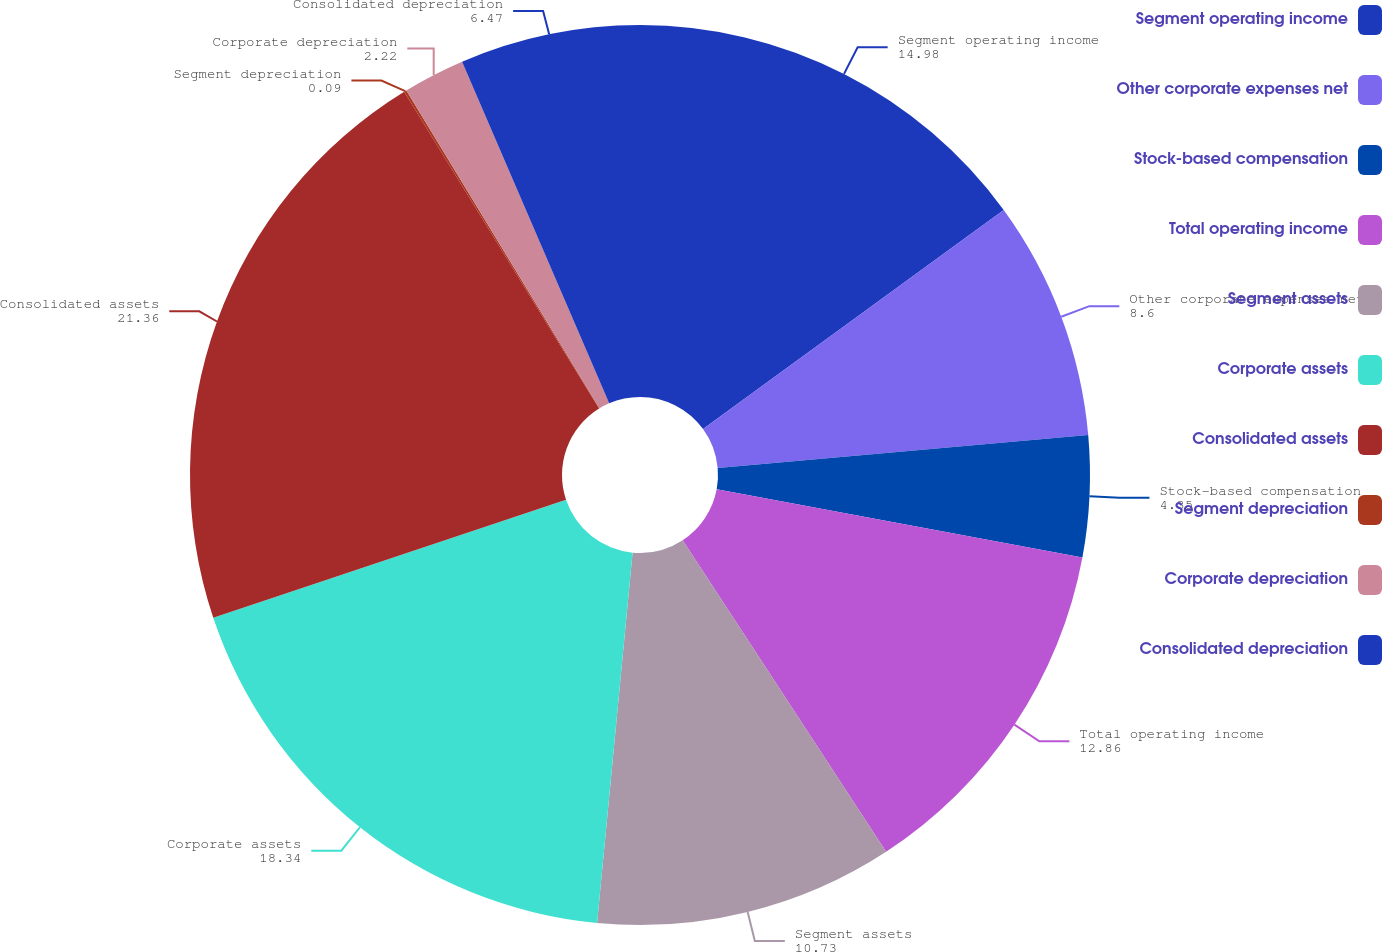Convert chart to OTSL. <chart><loc_0><loc_0><loc_500><loc_500><pie_chart><fcel>Segment operating income<fcel>Other corporate expenses net<fcel>Stock-based compensation<fcel>Total operating income<fcel>Segment assets<fcel>Corporate assets<fcel>Consolidated assets<fcel>Segment depreciation<fcel>Corporate depreciation<fcel>Consolidated depreciation<nl><fcel>14.98%<fcel>8.6%<fcel>4.35%<fcel>12.86%<fcel>10.73%<fcel>18.34%<fcel>21.36%<fcel>0.09%<fcel>2.22%<fcel>6.47%<nl></chart> 